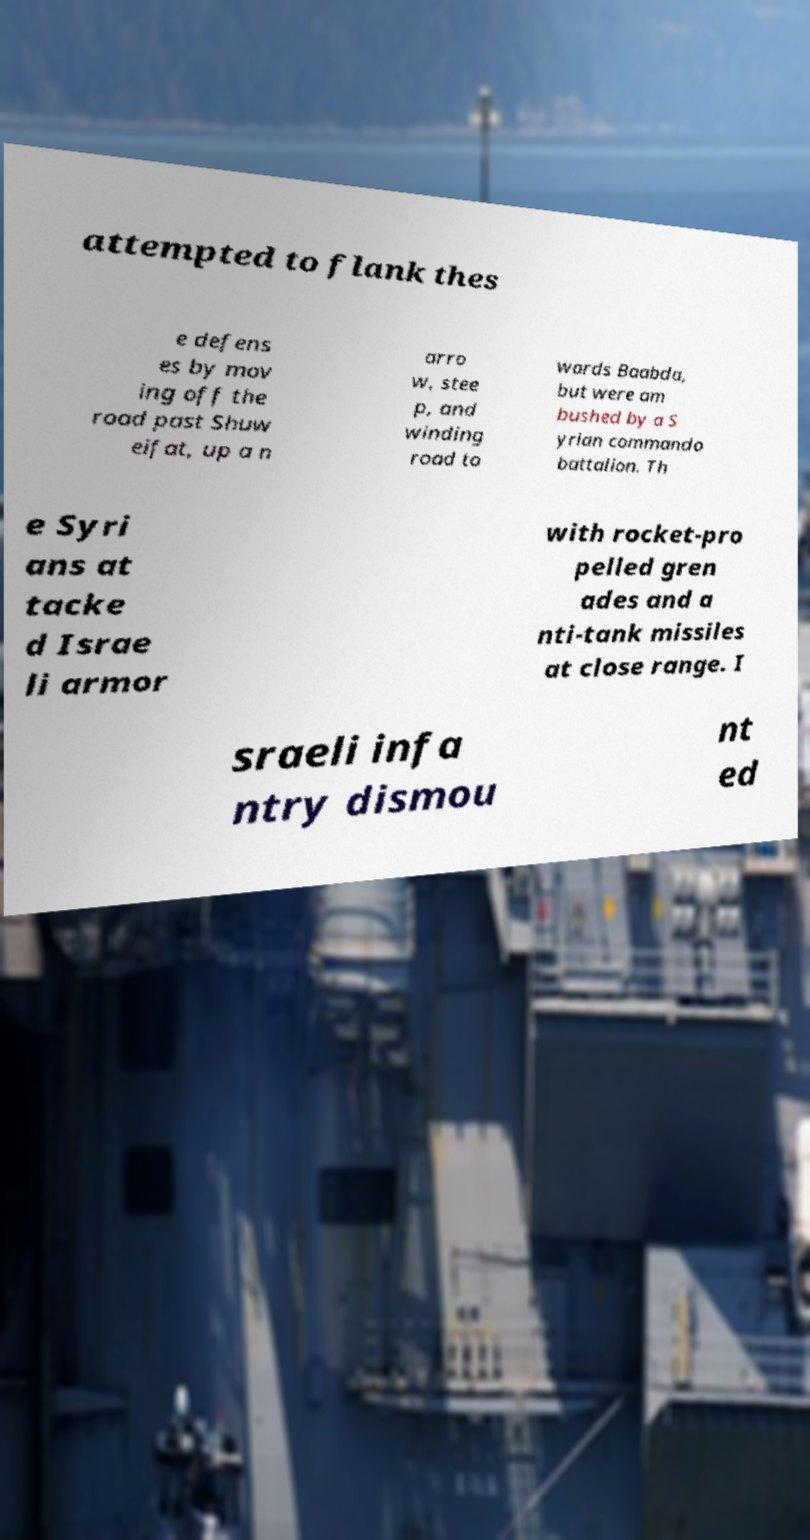There's text embedded in this image that I need extracted. Can you transcribe it verbatim? attempted to flank thes e defens es by mov ing off the road past Shuw eifat, up a n arro w, stee p, and winding road to wards Baabda, but were am bushed by a S yrian commando battalion. Th e Syri ans at tacke d Israe li armor with rocket-pro pelled gren ades and a nti-tank missiles at close range. I sraeli infa ntry dismou nt ed 